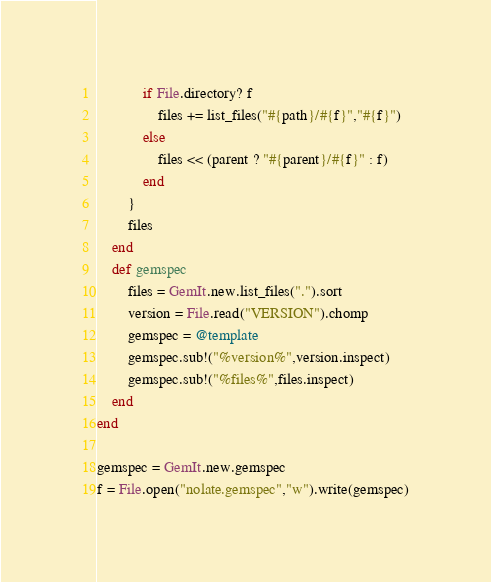<code> <loc_0><loc_0><loc_500><loc_500><_Ruby_>            if File.directory? f
                files += list_files("#{path}/#{f}","#{f}")
            else
                files << (parent ? "#{parent}/#{f}" : f)
            end
        }
        files
    end
    def gemspec
        files = GemIt.new.list_files(".").sort
        version = File.read("VERSION").chomp
        gemspec = @template
        gemspec.sub!("%version%",version.inspect)
        gemspec.sub!("%files%",files.inspect)
    end
end

gemspec = GemIt.new.gemspec
f = File.open("nolate.gemspec","w").write(gemspec)
</code> 